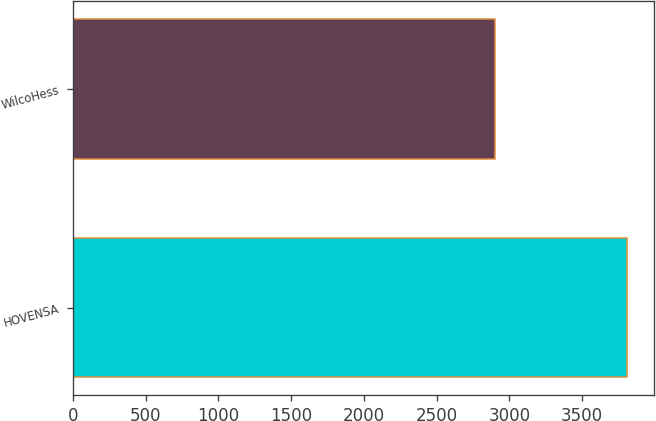<chart> <loc_0><loc_0><loc_500><loc_500><bar_chart><fcel>HOVENSA<fcel>WilcoHess<nl><fcel>3806<fcel>2898<nl></chart> 